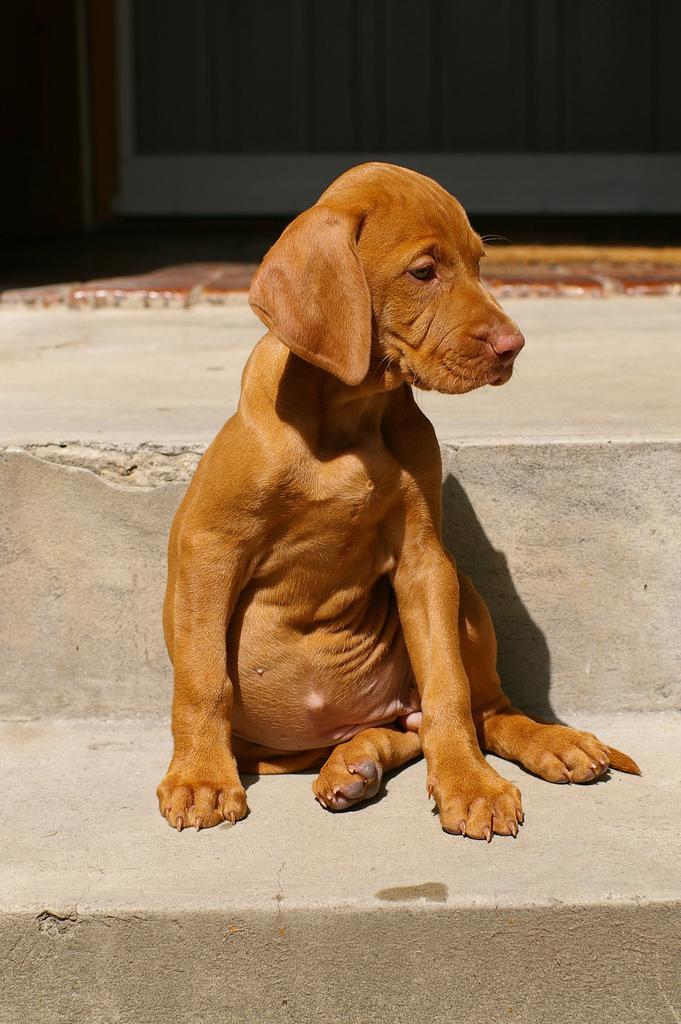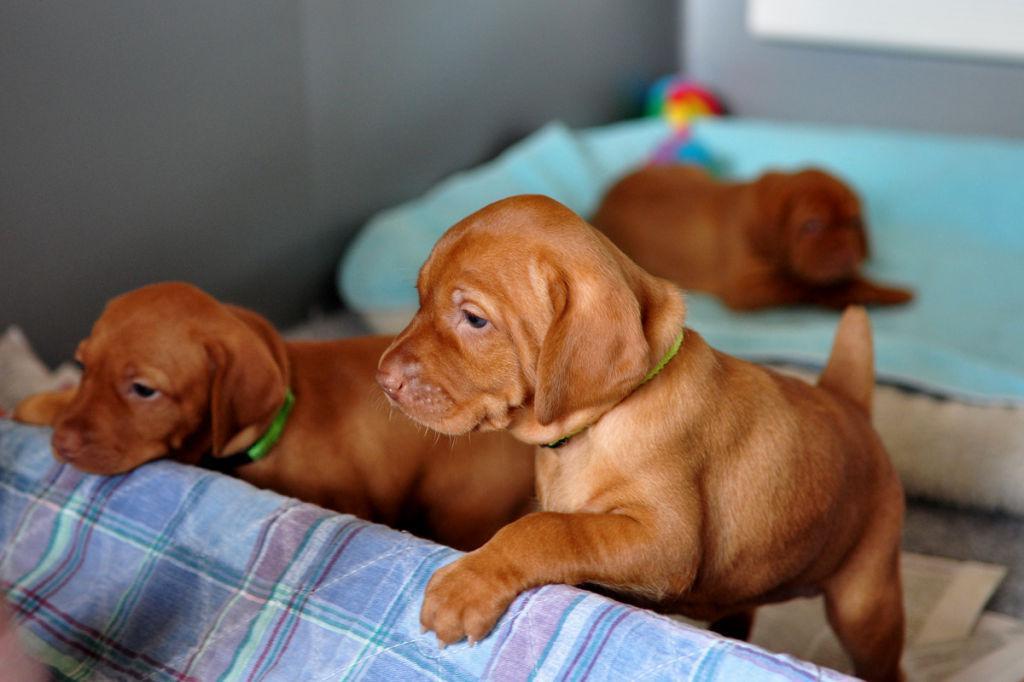The first image is the image on the left, the second image is the image on the right. Assess this claim about the two images: "There are at most 5 dogs in total.". Correct or not? Answer yes or no. Yes. 